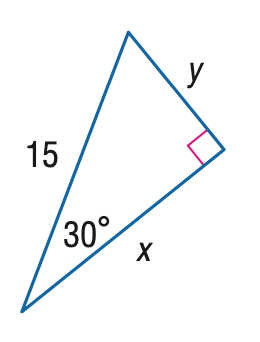Question: Find x.
Choices:
A. \frac { 15 } { 2 }
B. \frac { 15 } { 2 } \sqrt { 2 }
C. \frac { 15 } { 2 } \sqrt { 3 }
D. 15 \sqrt { 3 }
Answer with the letter. Answer: C 